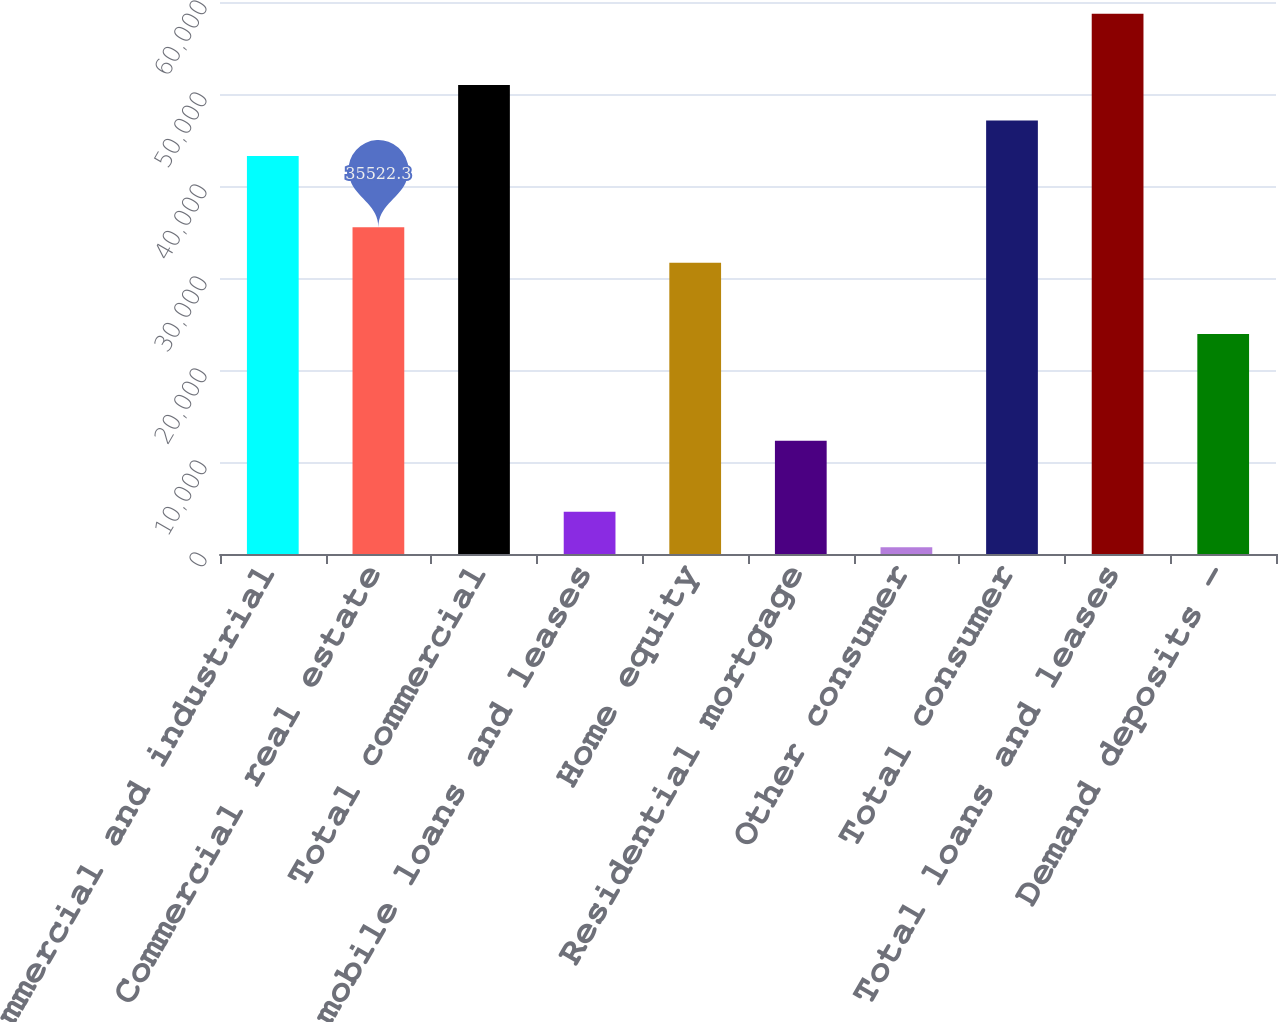Convert chart to OTSL. <chart><loc_0><loc_0><loc_500><loc_500><bar_chart><fcel>Commercial and industrial<fcel>Commercial real estate<fcel>Total commercial<fcel>Automobile loans and leases<fcel>Home equity<fcel>Residential mortgage<fcel>Other consumer<fcel>Total consumer<fcel>Total loans and leases<fcel>Demand deposits -<nl><fcel>43255.7<fcel>35522.3<fcel>50989.1<fcel>4588.7<fcel>31655.6<fcel>12322.1<fcel>722<fcel>47122.4<fcel>58722.5<fcel>23922.2<nl></chart> 